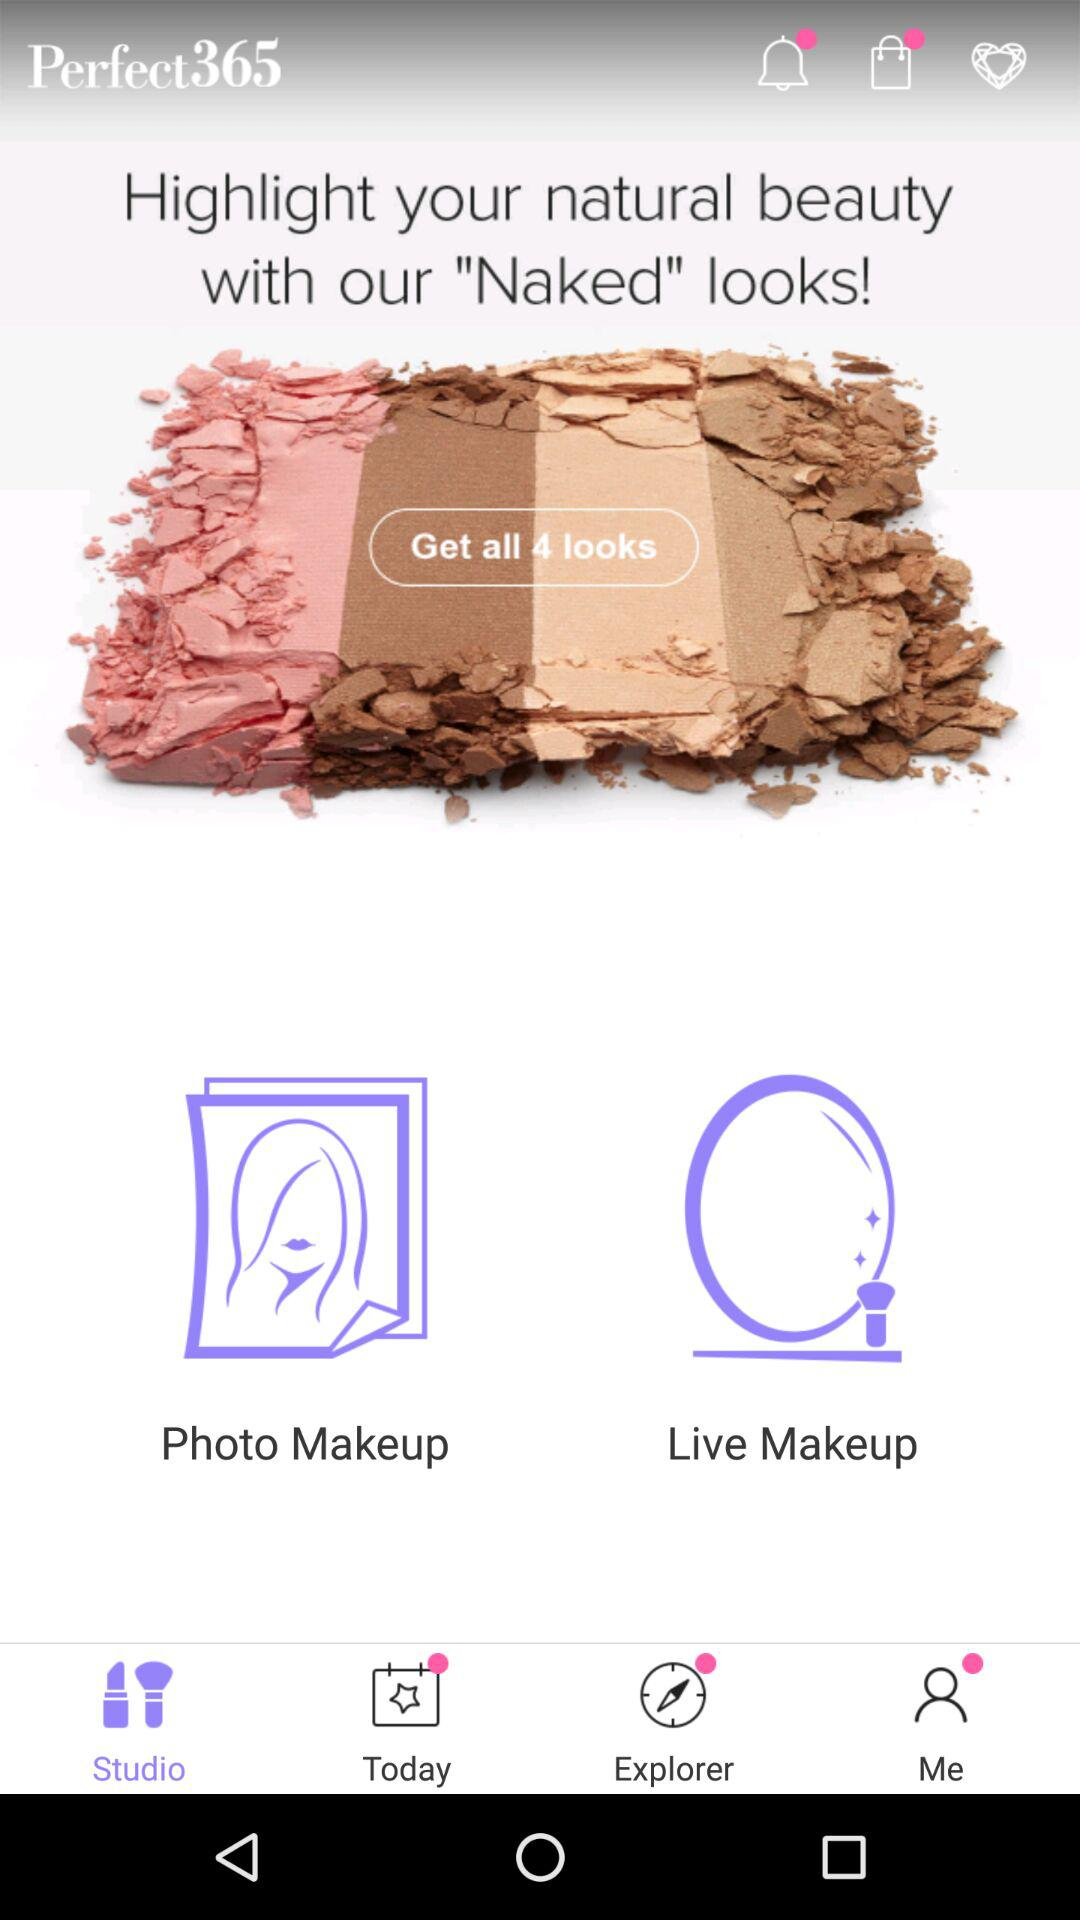How many looks are there? There are 4 looks. 